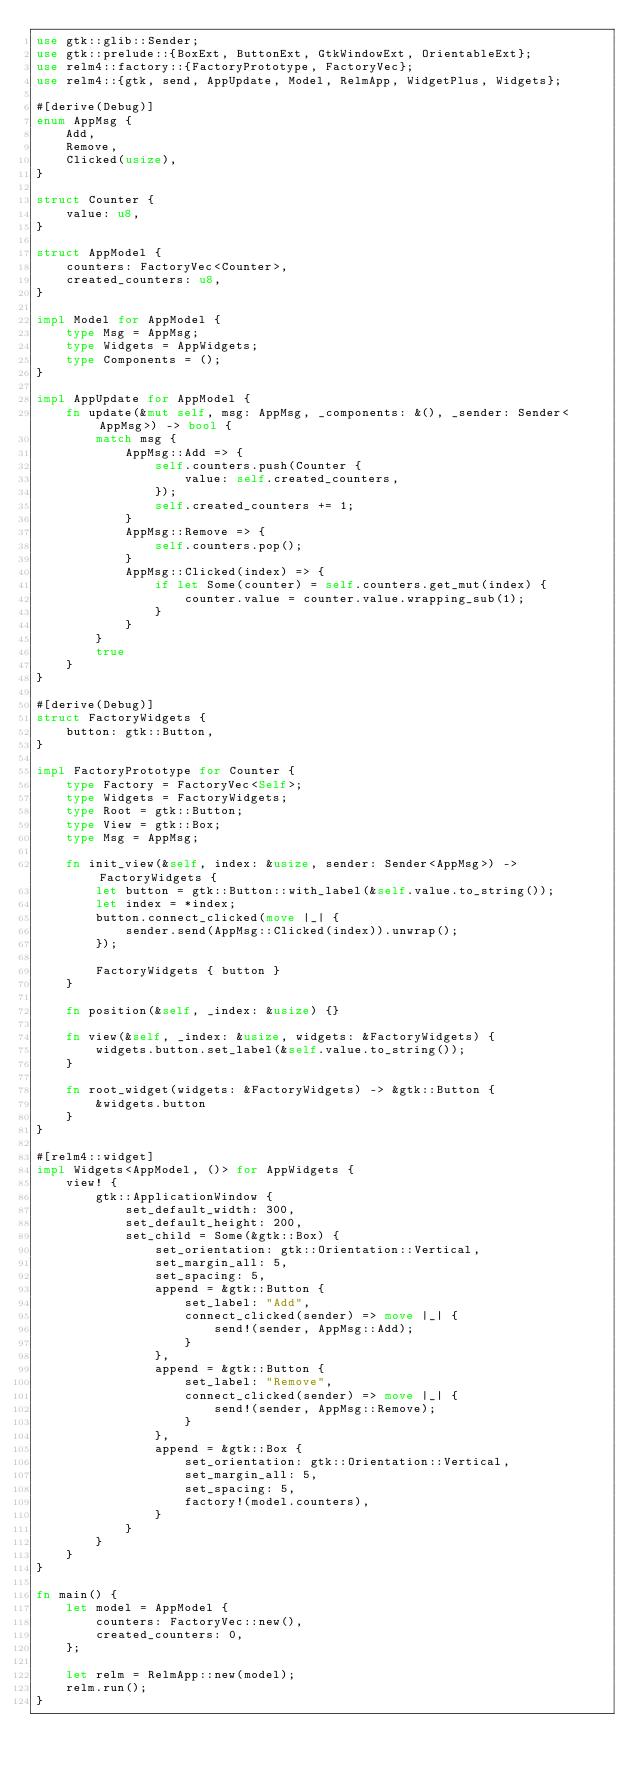Convert code to text. <code><loc_0><loc_0><loc_500><loc_500><_Rust_>use gtk::glib::Sender;
use gtk::prelude::{BoxExt, ButtonExt, GtkWindowExt, OrientableExt};
use relm4::factory::{FactoryPrototype, FactoryVec};
use relm4::{gtk, send, AppUpdate, Model, RelmApp, WidgetPlus, Widgets};

#[derive(Debug)]
enum AppMsg {
    Add,
    Remove,
    Clicked(usize),
}

struct Counter {
    value: u8,
}

struct AppModel {
    counters: FactoryVec<Counter>,
    created_counters: u8,
}

impl Model for AppModel {
    type Msg = AppMsg;
    type Widgets = AppWidgets;
    type Components = ();
}

impl AppUpdate for AppModel {
    fn update(&mut self, msg: AppMsg, _components: &(), _sender: Sender<AppMsg>) -> bool {
        match msg {
            AppMsg::Add => {
                self.counters.push(Counter {
                    value: self.created_counters,
                });
                self.created_counters += 1;
            }
            AppMsg::Remove => {
                self.counters.pop();
            }
            AppMsg::Clicked(index) => {
                if let Some(counter) = self.counters.get_mut(index) {
                    counter.value = counter.value.wrapping_sub(1);
                }
            }
        }
        true
    }
}

#[derive(Debug)]
struct FactoryWidgets {
    button: gtk::Button,
}

impl FactoryPrototype for Counter {
    type Factory = FactoryVec<Self>;
    type Widgets = FactoryWidgets;
    type Root = gtk::Button;
    type View = gtk::Box;
    type Msg = AppMsg;

    fn init_view(&self, index: &usize, sender: Sender<AppMsg>) -> FactoryWidgets {
        let button = gtk::Button::with_label(&self.value.to_string());
        let index = *index;
        button.connect_clicked(move |_| {
            sender.send(AppMsg::Clicked(index)).unwrap();
        });

        FactoryWidgets { button }
    }

    fn position(&self, _index: &usize) {}

    fn view(&self, _index: &usize, widgets: &FactoryWidgets) {
        widgets.button.set_label(&self.value.to_string());
    }

    fn root_widget(widgets: &FactoryWidgets) -> &gtk::Button {
        &widgets.button
    }
}

#[relm4::widget]
impl Widgets<AppModel, ()> for AppWidgets {
    view! {
        gtk::ApplicationWindow {
            set_default_width: 300,
            set_default_height: 200,
            set_child = Some(&gtk::Box) {
                set_orientation: gtk::Orientation::Vertical,
                set_margin_all: 5,
                set_spacing: 5,
                append = &gtk::Button {
                    set_label: "Add",
                    connect_clicked(sender) => move |_| {
                        send!(sender, AppMsg::Add);
                    }
                },
                append = &gtk::Button {
                    set_label: "Remove",
                    connect_clicked(sender) => move |_| {
                        send!(sender, AppMsg::Remove);
                    }
                },
                append = &gtk::Box {
                    set_orientation: gtk::Orientation::Vertical,
                    set_margin_all: 5,
                    set_spacing: 5,
                    factory!(model.counters),
                }
            }
        }
    }
}

fn main() {
    let model = AppModel {
        counters: FactoryVec::new(),
        created_counters: 0,
    };

    let relm = RelmApp::new(model);
    relm.run();
}
</code> 